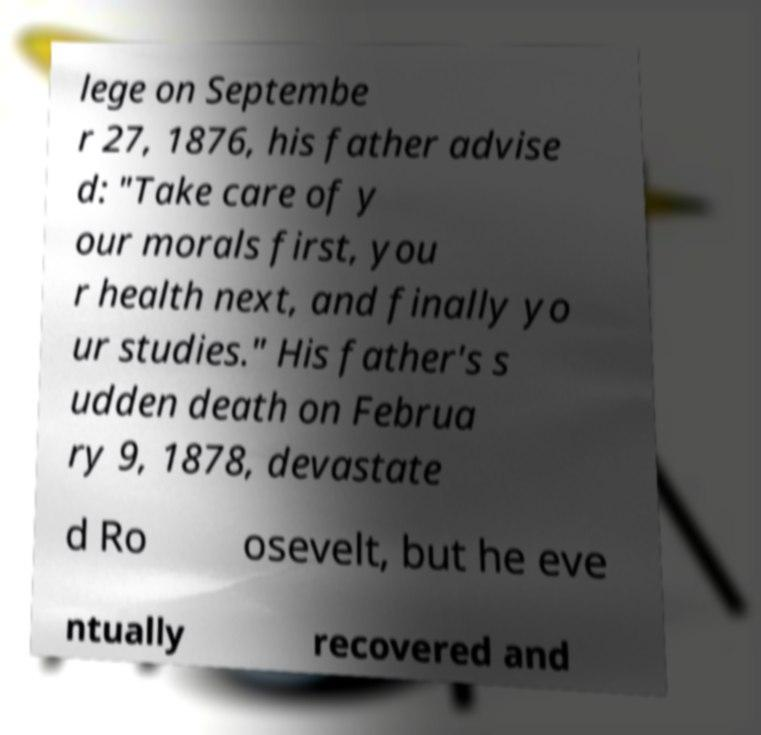Could you extract and type out the text from this image? lege on Septembe r 27, 1876, his father advise d: "Take care of y our morals first, you r health next, and finally yo ur studies." His father's s udden death on Februa ry 9, 1878, devastate d Ro osevelt, but he eve ntually recovered and 